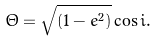Convert formula to latex. <formula><loc_0><loc_0><loc_500><loc_500>\Theta = \sqrt { ( 1 - e ^ { 2 } ) } \cos i .</formula> 